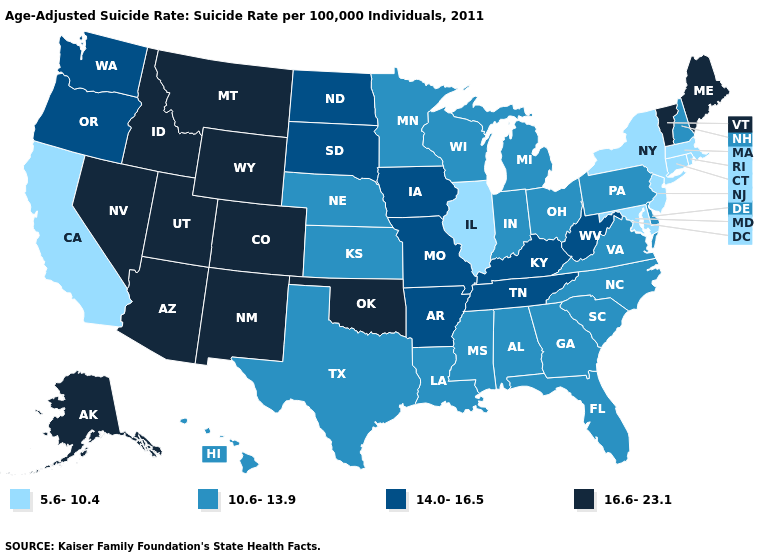Does Nebraska have the lowest value in the MidWest?
Quick response, please. No. What is the lowest value in the USA?
Give a very brief answer. 5.6-10.4. What is the highest value in the West ?
Give a very brief answer. 16.6-23.1. How many symbols are there in the legend?
Give a very brief answer. 4. Does Oklahoma have the highest value in the USA?
Concise answer only. Yes. Does Arkansas have the lowest value in the USA?
Concise answer only. No. Among the states that border Pennsylvania , which have the highest value?
Answer briefly. West Virginia. What is the lowest value in the USA?
Write a very short answer. 5.6-10.4. Among the states that border Pennsylvania , does West Virginia have the highest value?
Concise answer only. Yes. Name the states that have a value in the range 10.6-13.9?
Short answer required. Alabama, Delaware, Florida, Georgia, Hawaii, Indiana, Kansas, Louisiana, Michigan, Minnesota, Mississippi, Nebraska, New Hampshire, North Carolina, Ohio, Pennsylvania, South Carolina, Texas, Virginia, Wisconsin. What is the lowest value in states that border Georgia?
Answer briefly. 10.6-13.9. Does New Mexico have the highest value in the West?
Concise answer only. Yes. Is the legend a continuous bar?
Give a very brief answer. No. What is the highest value in the USA?
Quick response, please. 16.6-23.1. Does Arizona have the highest value in the West?
Concise answer only. Yes. 